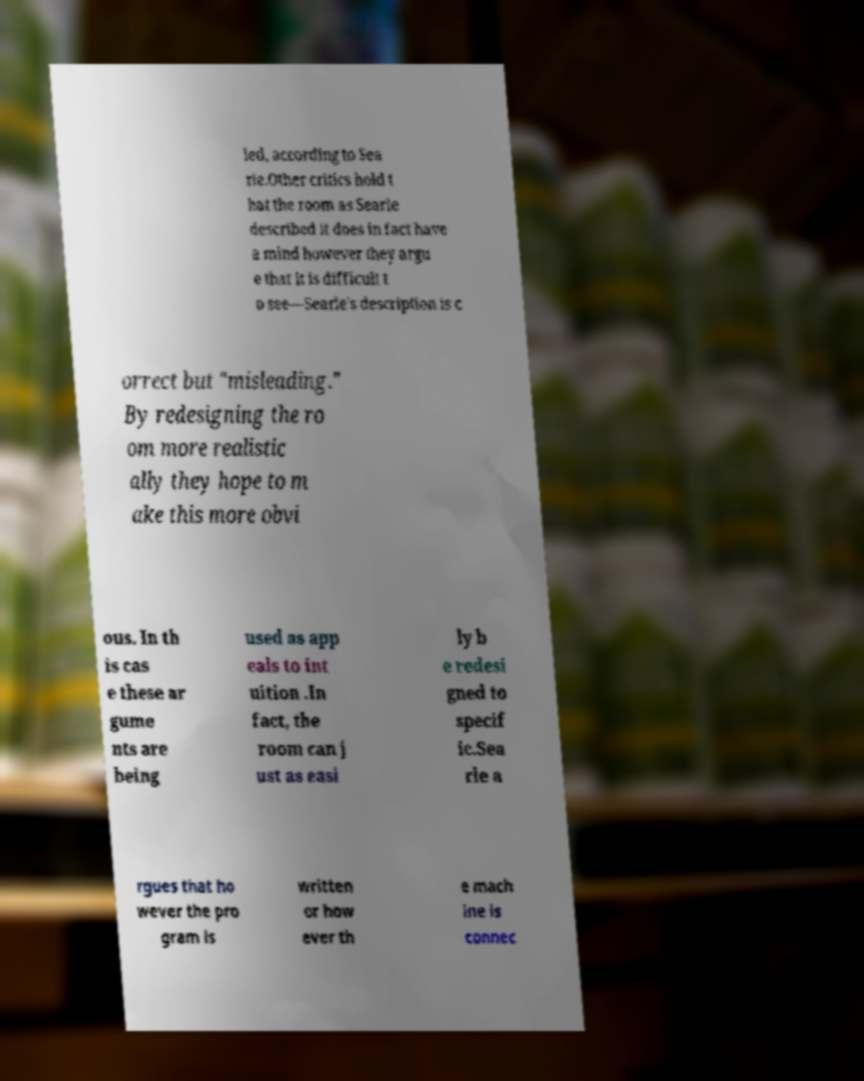Could you extract and type out the text from this image? led, according to Sea rle.Other critics hold t hat the room as Searle described it does in fact have a mind however they argu e that it is difficult t o see—Searle's description is c orrect but "misleading." By redesigning the ro om more realistic ally they hope to m ake this more obvi ous. In th is cas e these ar gume nts are being used as app eals to int uition .In fact, the room can j ust as easi ly b e redesi gned to specif ic.Sea rle a rgues that ho wever the pro gram is written or how ever th e mach ine is connec 